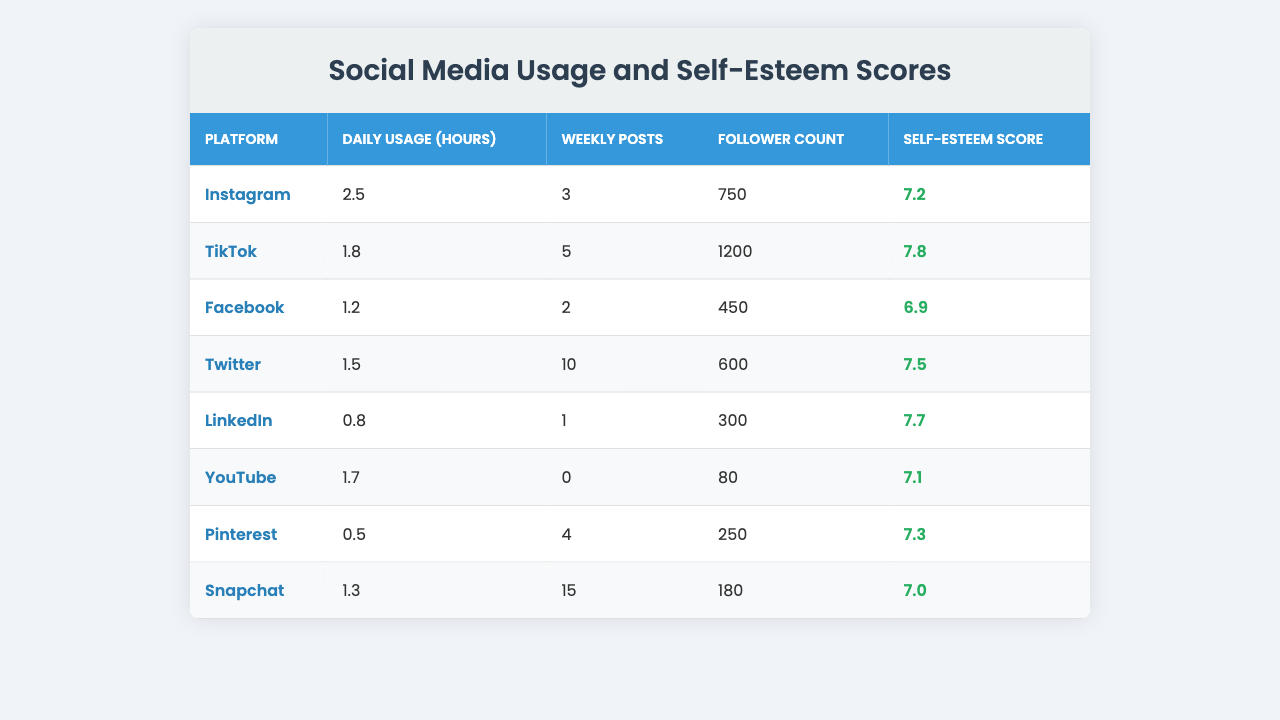What is the self-esteem score for TikTok? The table clearly shows that TikTok has a self-esteem score of 7.8.
Answer: 7.8 Which platform has the highest self-esteem score? By comparing the self-esteem scores in the table, TikTok has the highest score at 7.8.
Answer: TikTok What is the average self-esteem score across all platforms? To find the average, first sum the self-esteem scores: (7.2 + 7.8 + 6.9 + 7.5 + 7.7 + 7.1 + 7.3 + 7.0) = 59.5. Then divide by 8 (the number of platforms): 59.5 / 8 = 7.4375. Rounded to two decimal places, the average is 7.44.
Answer: 7.44 Does Facebook have a higher self-esteem score than LinkedIn? Facebook has a self-esteem score of 6.9 and LinkedIn has a score of 7.7; since 6.9 < 7.7, Facebook does not have a higher score than LinkedIn.
Answer: No What is the total number of weekly posts across all platforms? Sum the weekly posts from each platform: (3 + 5 + 2 + 10 + 1 + 0 + 4 + 15) = 40. Thus, the total is 40 weekly posts.
Answer: 40 Is there a correlation between daily usage hours and self-esteem scores? To determine correlation visually, we can see that platforms with more hours like Instagram (2.5 hours) and TikTok (1.8 hours) have higher self-esteem scores. However, a thorough analysis would need statistical tools; thus, it is suggestive but not definitive.
Answer: Suggestive Which platform has the least daily usage hours? Looking through the table, Pinterest has the least daily usage at 0.5 hours.
Answer: Pinterest If you combine Instagram and Twitter's self-esteem scores, what is their sum? Instagram's score is 7.2 and Twitter's is 7.5, so their sum is 7.2 + 7.5 = 14.7.
Answer: 14.7 Which platform has more followers, Instagram or Snapchat? Instagram has 750 followers and Snapchat has 180 followers; therefore, Instagram has more followers than Snapchat.
Answer: Instagram How many platforms have a self-esteem score above 7? By inspecting the self-esteem scores, we see that Instagram, TikTok, Twitter, LinkedIn, and Pinterest have scores above 7, totaling 5 platforms.
Answer: 5 